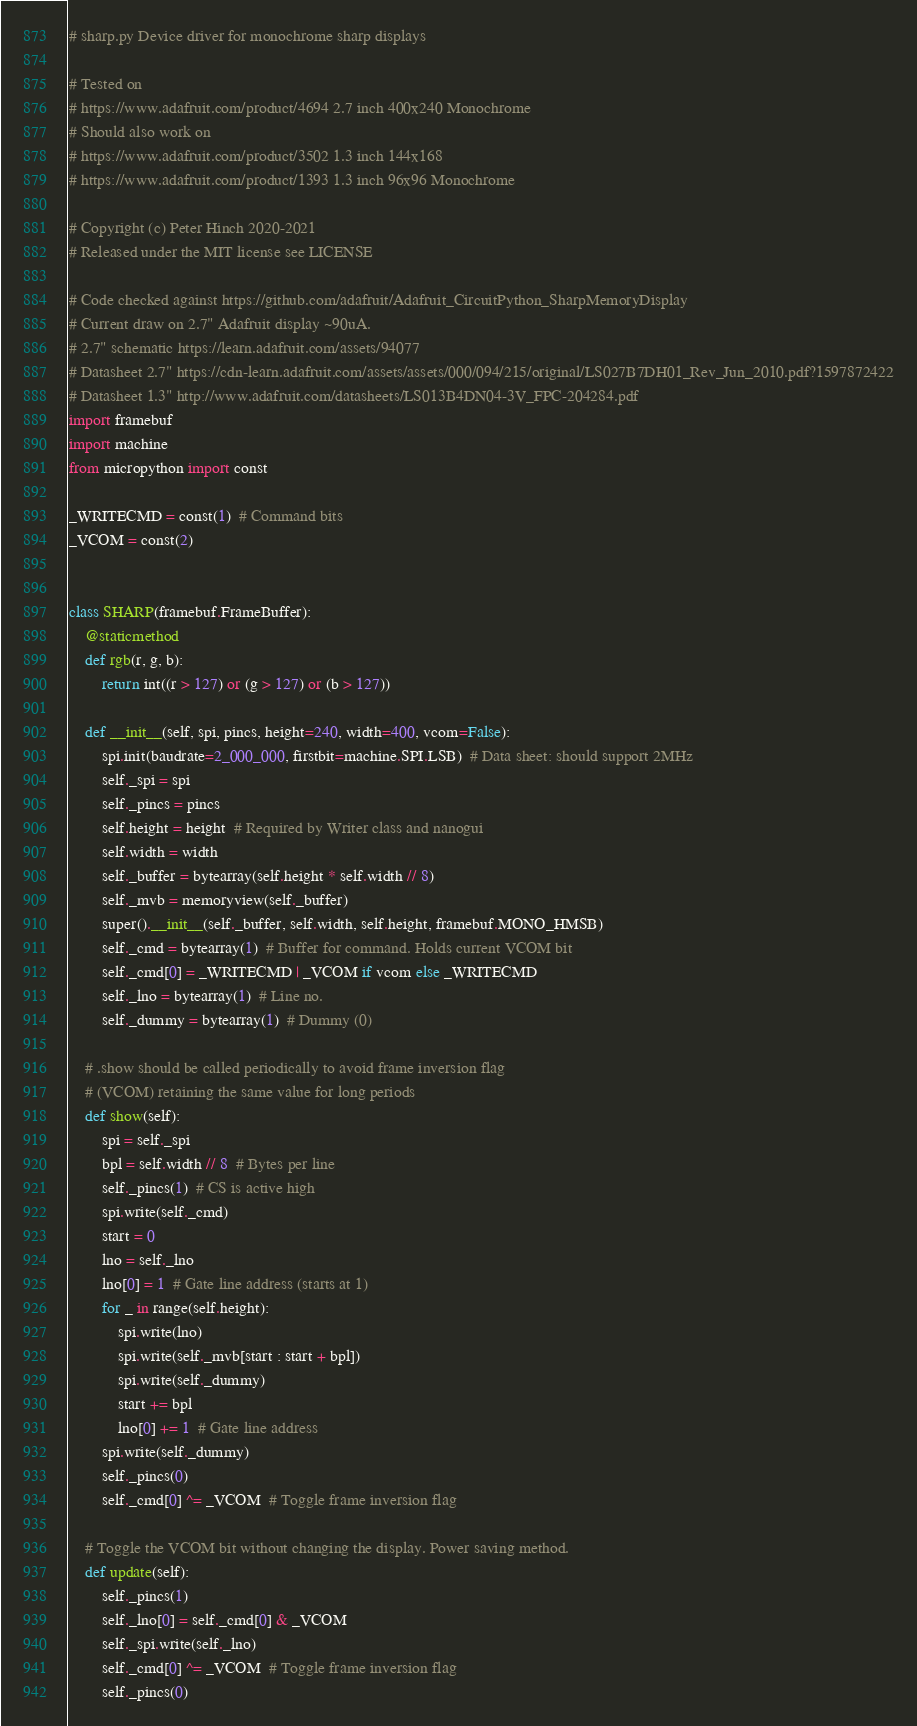Convert code to text. <code><loc_0><loc_0><loc_500><loc_500><_Python_># sharp.py Device driver for monochrome sharp displays

# Tested on
# https://www.adafruit.com/product/4694 2.7 inch 400x240 Monochrome
# Should also work on
# https://www.adafruit.com/product/3502 1.3 inch 144x168
# https://www.adafruit.com/product/1393 1.3 inch 96x96 Monochrome

# Copyright (c) Peter Hinch 2020-2021
# Released under the MIT license see LICENSE

# Code checked against https://github.com/adafruit/Adafruit_CircuitPython_SharpMemoryDisplay
# Current draw on 2.7" Adafruit display ~90uA.
# 2.7" schematic https://learn.adafruit.com/assets/94077
# Datasheet 2.7" https://cdn-learn.adafruit.com/assets/assets/000/094/215/original/LS027B7DH01_Rev_Jun_2010.pdf?1597872422
# Datasheet 1.3" http://www.adafruit.com/datasheets/LS013B4DN04-3V_FPC-204284.pdf
import framebuf
import machine
from micropython import const

_WRITECMD = const(1)  # Command bits
_VCOM = const(2)


class SHARP(framebuf.FrameBuffer):
    @staticmethod
    def rgb(r, g, b):
        return int((r > 127) or (g > 127) or (b > 127))

    def __init__(self, spi, pincs, height=240, width=400, vcom=False):
        spi.init(baudrate=2_000_000, firstbit=machine.SPI.LSB)  # Data sheet: should support 2MHz
        self._spi = spi
        self._pincs = pincs
        self.height = height  # Required by Writer class and nanogui
        self.width = width
        self._buffer = bytearray(self.height * self.width // 8)
        self._mvb = memoryview(self._buffer)
        super().__init__(self._buffer, self.width, self.height, framebuf.MONO_HMSB)
        self._cmd = bytearray(1)  # Buffer for command. Holds current VCOM bit
        self._cmd[0] = _WRITECMD | _VCOM if vcom else _WRITECMD
        self._lno = bytearray(1)  # Line no.
        self._dummy = bytearray(1)  # Dummy (0)

    # .show should be called periodically to avoid frame inversion flag
    # (VCOM) retaining the same value for long periods
    def show(self):
        spi = self._spi
        bpl = self.width // 8  # Bytes per line
        self._pincs(1)  # CS is active high
        spi.write(self._cmd)
        start = 0
        lno = self._lno
        lno[0] = 1  # Gate line address (starts at 1)
        for _ in range(self.height):
            spi.write(lno)
            spi.write(self._mvb[start : start + bpl])
            spi.write(self._dummy)
            start += bpl
            lno[0] += 1  # Gate line address
        spi.write(self._dummy)
        self._pincs(0)
        self._cmd[0] ^= _VCOM  # Toggle frame inversion flag

    # Toggle the VCOM bit without changing the display. Power saving method.
    def update(self):
        self._pincs(1)
        self._lno[0] = self._cmd[0] & _VCOM
        self._spi.write(self._lno)
        self._cmd[0] ^= _VCOM  # Toggle frame inversion flag
        self._pincs(0)
</code> 